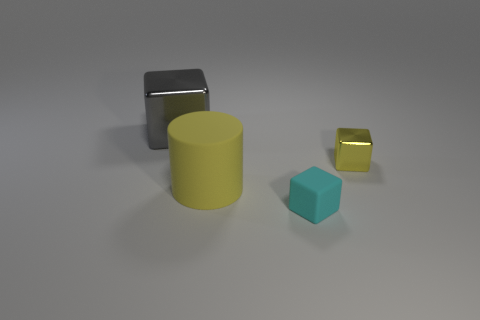There is a shiny object on the left side of the small cyan rubber cube; are there any big things right of it?
Your answer should be very brief. Yes. How many things are either gray metallic objects or rubber cylinders?
Provide a short and direct response. 2. What color is the object that is on the left side of the large thing that is in front of the metal block that is behind the yellow metallic object?
Ensure brevity in your answer.  Gray. Are there any other things of the same color as the tiny rubber cube?
Keep it short and to the point. No. Is the size of the yellow matte cylinder the same as the cyan block?
Offer a very short reply. No. What number of things are either large objects that are in front of the yellow shiny object or things behind the cyan block?
Keep it short and to the point. 3. The small cube that is behind the big object that is in front of the large gray thing is made of what material?
Make the answer very short. Metal. How many other objects are the same material as the yellow cylinder?
Offer a very short reply. 1. Is the small cyan thing the same shape as the large yellow rubber object?
Offer a very short reply. No. How big is the metallic cube that is on the left side of the yellow cylinder?
Provide a succinct answer. Large. 